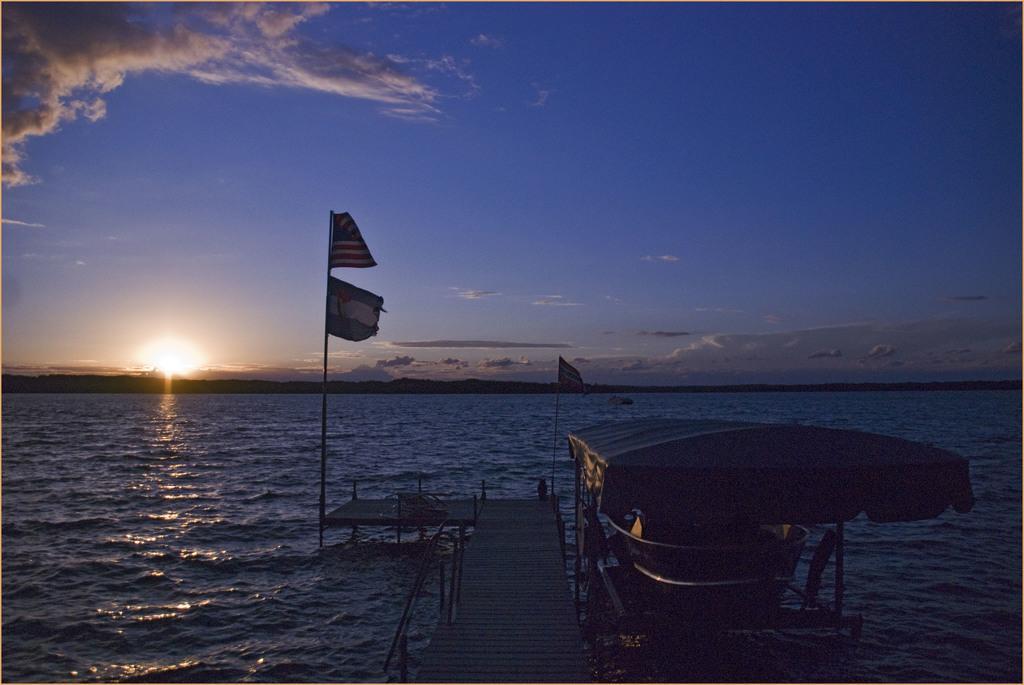Describe this image in one or two sentences. In this image we can see sky with clouds, sun, water, walkway bridge, flags and a ship. 